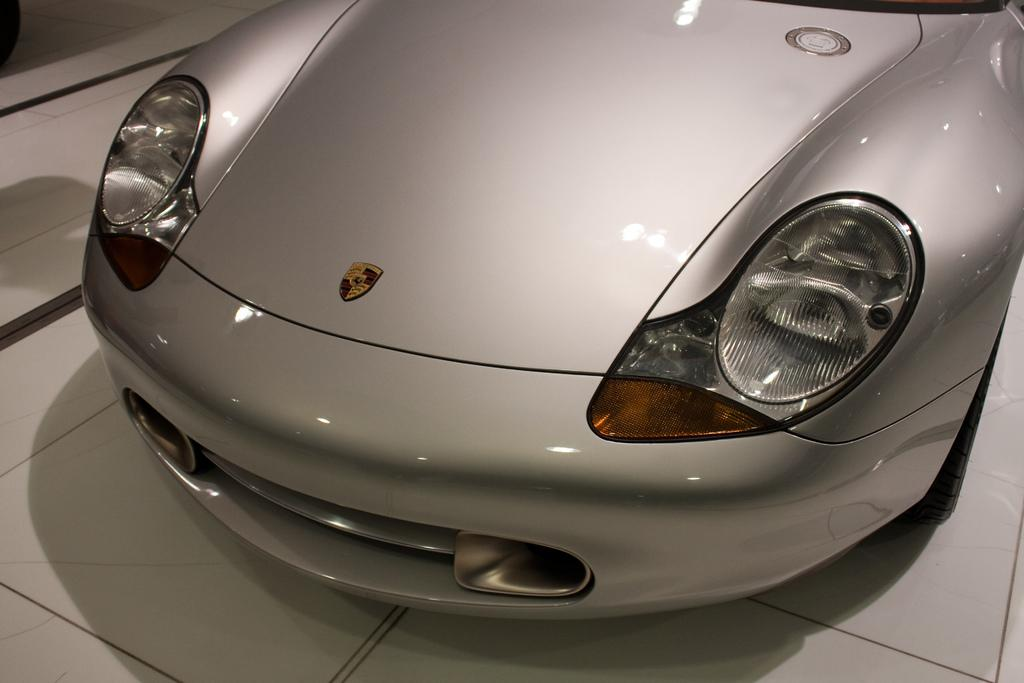What is the main subject of the image? There is a vehicle in the image. What color is the vehicle? The vehicle is in an ash color. What is the color of the surface the vehicle is on? The vehicle is on a white color surface. What type of mine can be seen in the image? There is no mine present in the image; it features a vehicle on a white surface. Can you tell me how many judges are visible in the image? There are no judges present in the image. 